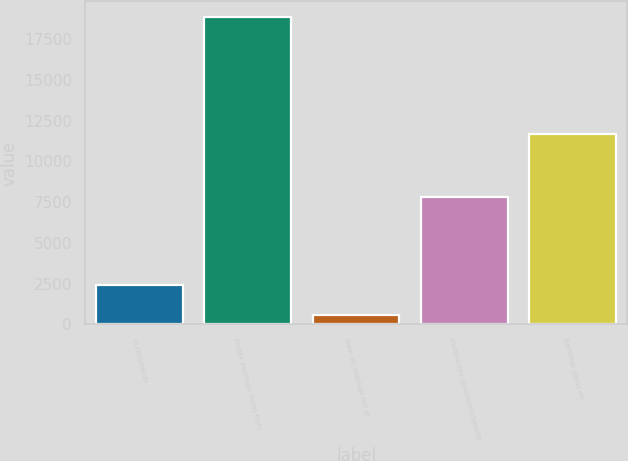<chart> <loc_0><loc_0><loc_500><loc_500><bar_chart><fcel>in thousands<fcel>Pretax earnings (loss) from<fcel>Gain on disposal net of<fcel>Income tax (provision) benefit<fcel>Earnings (loss) on<nl><fcel>2412.8<fcel>18872<fcel>584<fcel>7790<fcel>11666<nl></chart> 